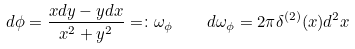Convert formula to latex. <formula><loc_0><loc_0><loc_500><loc_500>d \phi = \frac { x d y - y d x } { x ^ { 2 } + y ^ { 2 } } = \colon \omega _ { \phi } \quad d \omega _ { \phi } = 2 \pi \delta ^ { ( 2 ) } ( x ) d ^ { 2 } x</formula> 